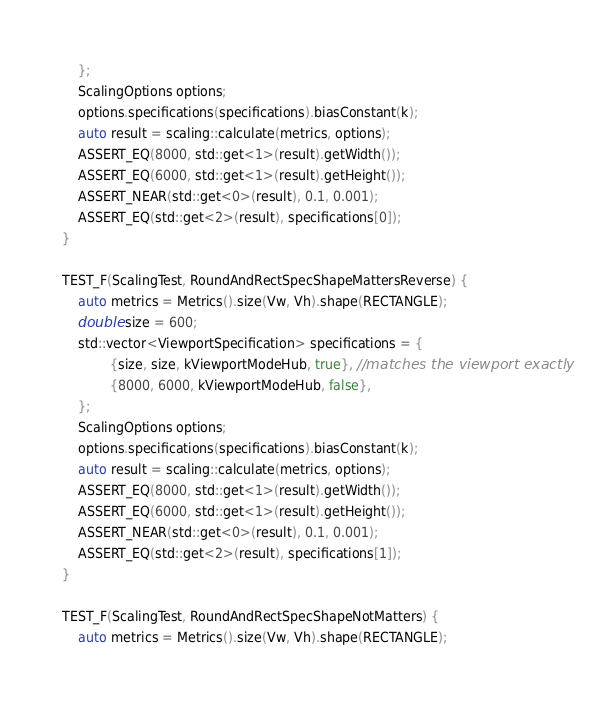Convert code to text. <code><loc_0><loc_0><loc_500><loc_500><_C++_>    };
    ScalingOptions options;
    options.specifications(specifications).biasConstant(k);
    auto result = scaling::calculate(metrics, options);
    ASSERT_EQ(8000, std::get<1>(result).getWidth());
    ASSERT_EQ(6000, std::get<1>(result).getHeight());
    ASSERT_NEAR(std::get<0>(result), 0.1, 0.001);
    ASSERT_EQ(std::get<2>(result), specifications[0]);
}

TEST_F(ScalingTest, RoundAndRectSpecShapeMattersReverse) {
    auto metrics = Metrics().size(Vw, Vh).shape(RECTANGLE);
    double size = 600;
    std::vector<ViewportSpecification> specifications = {
            {size, size, kViewportModeHub, true}, //matches the viewport exactly
            {8000, 6000, kViewportModeHub, false},
    };
    ScalingOptions options;
    options.specifications(specifications).biasConstant(k);
    auto result = scaling::calculate(metrics, options);
    ASSERT_EQ(8000, std::get<1>(result).getWidth());
    ASSERT_EQ(6000, std::get<1>(result).getHeight());
    ASSERT_NEAR(std::get<0>(result), 0.1, 0.001);
    ASSERT_EQ(std::get<2>(result), specifications[1]);
}

TEST_F(ScalingTest, RoundAndRectSpecShapeNotMatters) {
    auto metrics = Metrics().size(Vw, Vh).shape(RECTANGLE);</code> 